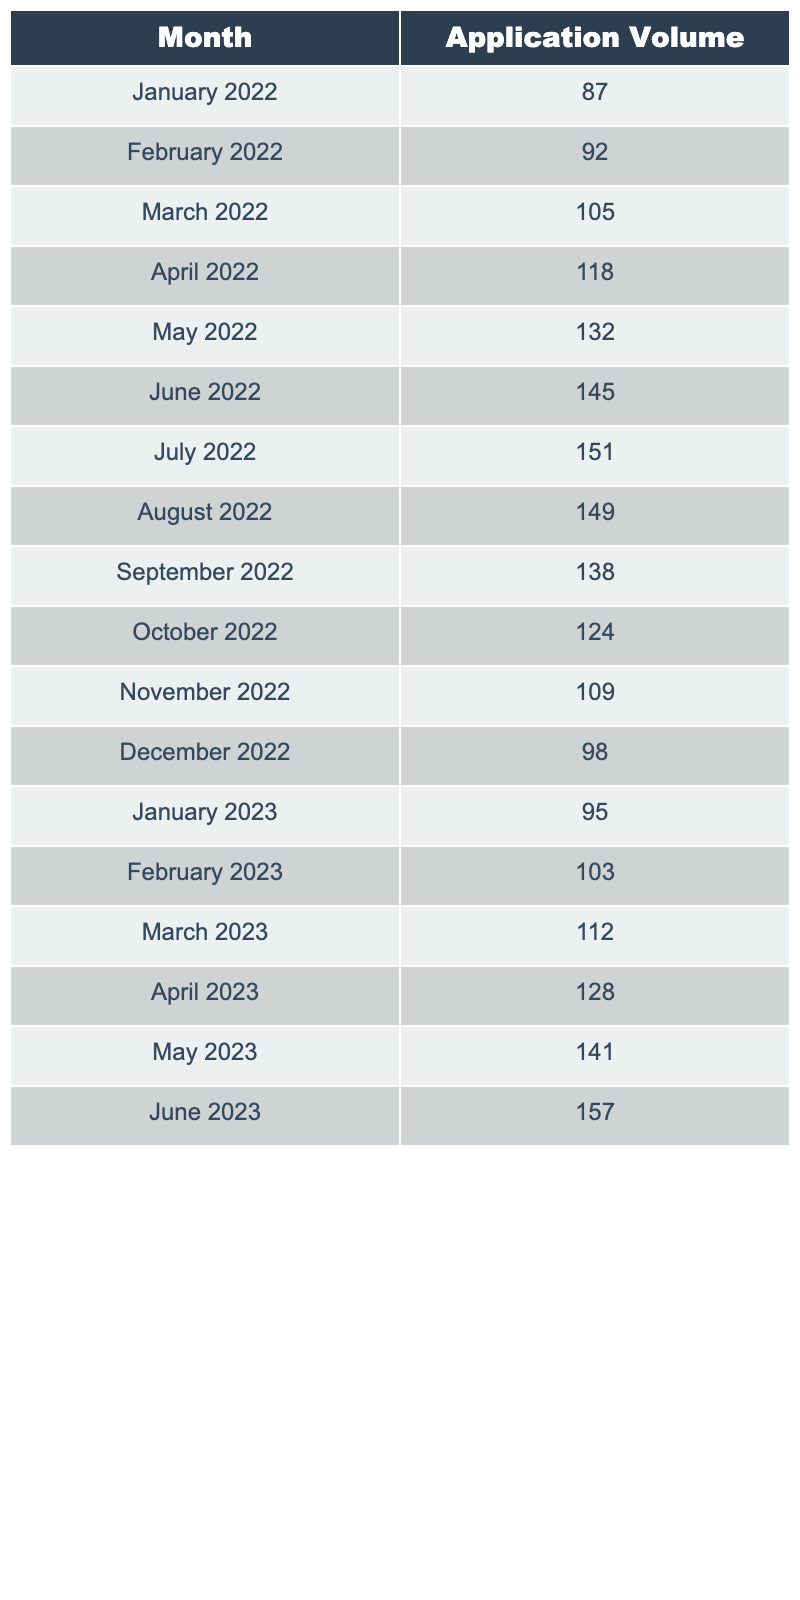What was the application volume in June 2022? In the table, the row for June 2022 shows an application volume of 145.
Answer: 145 Which month recorded the highest application volume? By reviewing the application volumes listed for each month, July 2022 shows the highest volume at 151.
Answer: July 2022 What is the average application volume for the year 2023? The application volumes for 2023 are: 95, 103, 112, 128, 141, and 157. Summing these gives 95 + 103 + 112 + 128 + 141 + 157 = 736. Dividing by the number of months (6) gives an average of 736/6 = 122.67.
Answer: 122.67 Did the application volume increase from January 2023 to June 2023? Comparing the figures, January 2023 has a volume of 95, and June 2023 has a volume of 157. Since 157 is greater than 95, the volume increased during this period.
Answer: Yes What is the difference in application volume between the highest and lowest months of 2022? The highest application volume in 2022 is 151 (July), and the lowest is 87 (January). The difference is calculated as 151 - 87 = 64.
Answer: 64 How many months had an application volume greater than 130 from January to June 2023? Reviewing the monthly volumes: January (95), February (103), March (112), April (128), May (141), June (157); only May (141) and June (157) exceed 130. Thus, there are 2 months.
Answer: 2 What percentage of the total application volume for 2022 does December's volume represent? The total application volume for 2022 is 87 + 92 + 105 + 118 + 132 + 145 + 151 + 149 + 138 + 124 + 109 + 98 = 1,588. December's volume is 98. The percentage is (98 / 1588) * 100 ≈ 6.17%.
Answer: 6.17% Which months had application volumes that were below the average for 2022? The average application volume for 2022 is calculated as 1,588 / 12 = 132.33. The months with volumes below this are January (87), February (92), March (105), November (109), and December (98), which totals 5 months.
Answer: 5 What was the trend of application volumes from January to June 2023? By comparing the monthly values, it shows a consistent increase from 95 to 157, with each month succeeding the previous one. Therefore, the trend is upward.
Answer: Upward How many months had an application volume of more than 140 in 2022? In 2022, the months with volumes greater than 140 are June (145), July (151), and August (149), making a total of 3 months.
Answer: 3 